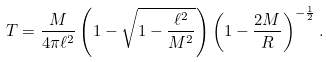Convert formula to latex. <formula><loc_0><loc_0><loc_500><loc_500>T = \frac { M } { 4 \pi \ell ^ { 2 } } \left ( 1 - \sqrt { 1 - \frac { \ell ^ { 2 } } { M ^ { 2 } } } \right ) \left ( 1 - \frac { 2 M } { R } \right ) ^ { - \frac { 1 } { 2 } } .</formula> 